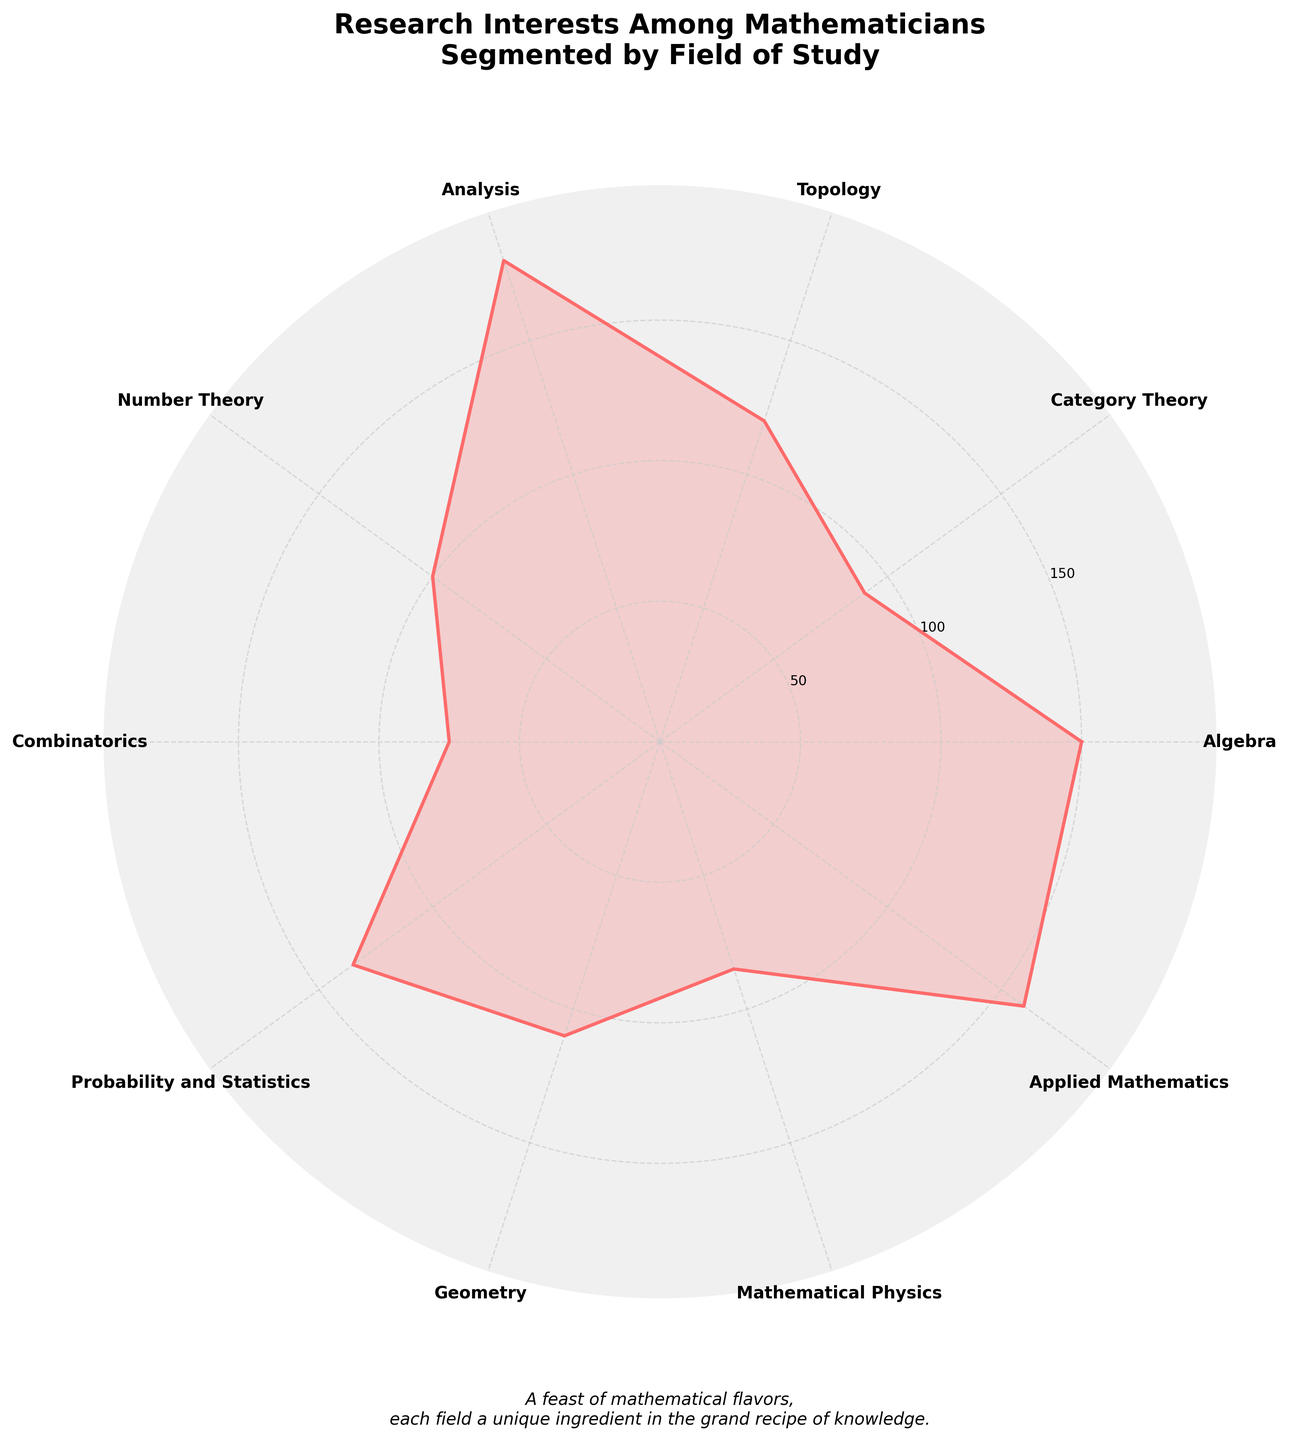what is the title of the figure? The title of the figure is located at the top and is clearly displayed. Just by reading it, we learn that it is: "Research Interests Among Mathematicians Segmented by Field of Study".
Answer: Research Interests Among Mathematicians Segmented by Field of Study which field has the highest number of researchers? By looking at the lengths of the radial segments, the longest one corresponds to the field of Analysis, which has the highest number of researchers.
Answer: Analysis how many fields have more than 100 researchers? To determine this, we need to count the segments with lengths exceeding the 100-mark. There are six fields: Algebra, Topology, Analysis, Probability and Statistics, Applied Mathematics, and Geometry.
Answer: Six what is the median number of researchers among all fields? To find the median, we first list the number of researchers in each field: 150, 90, 120, 180, 100, 75, 135, 110, 85, 160. Arranged in ascending order: 75, 85, 90, 100, 110, 120, 135, 150, 160, 180. The median is the average of the 5th and 6th values: (110 + 120) / 2 = 115.
Answer: 115 which fields have fewer researchers than Combinatorics? Combinatorics has 75 researchers. By comparing it with the other fields, we see that all other fields have more researchers than Combinatorics. Thus, none have fewer researchers.
Answer: None what’s the difference between the maximum and minimum number of researchers? The maximum number of researchers is in Analysis (180), and the minimum is in Combinatorics (75). The difference is 180 - 75 = 105.
Answer: 105 how many fields have a representation less than the average number of researchers across all fields? First, calculate the average number of researchers: (150 + 90 + 120 + 180 + 100 + 75 + 135 + 110 + 85 + 160) / 10 = 120.5. Fields with fewer than 120.5 researchers are: Category Theory, Number Theory, Combinatorics, Geometry, and Mathematical Physics, totaling five fields.
Answer: Five in which field is the number of researchers closest to the average number of researchers across all fields? The average is calculated as 120.5. Comparing the values, Topology has 120 researchers, which is the closest to the average.
Answer: Topology 